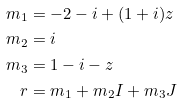Convert formula to latex. <formula><loc_0><loc_0><loc_500><loc_500>m _ { 1 } & = - 2 - i + ( 1 + i ) z \\ m _ { 2 } & = i \\ m _ { 3 } & = 1 - i - z \\ r & = m _ { 1 } + m _ { 2 } I + m _ { 3 } J</formula> 